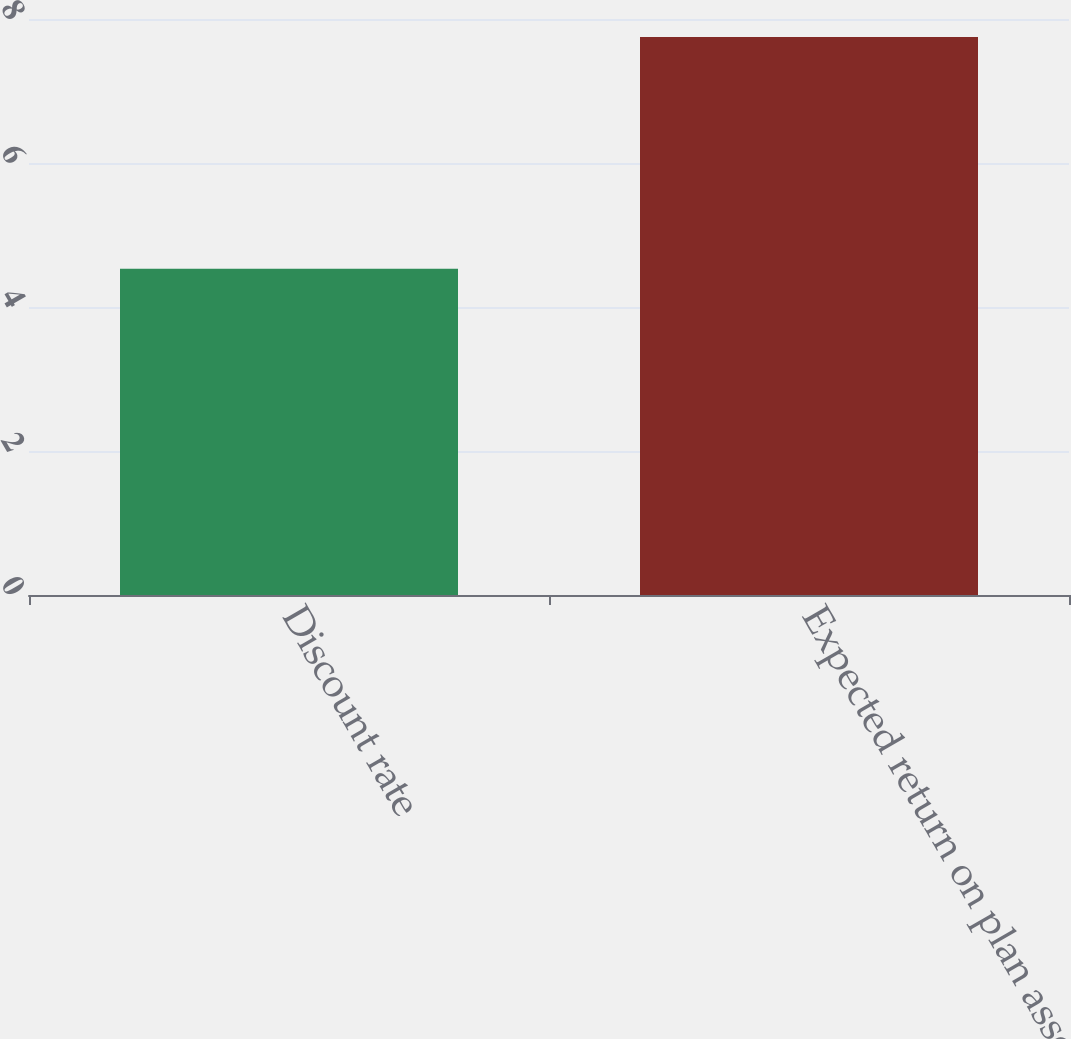<chart> <loc_0><loc_0><loc_500><loc_500><bar_chart><fcel>Discount rate<fcel>Expected return on plan assets<nl><fcel>4.53<fcel>7.75<nl></chart> 